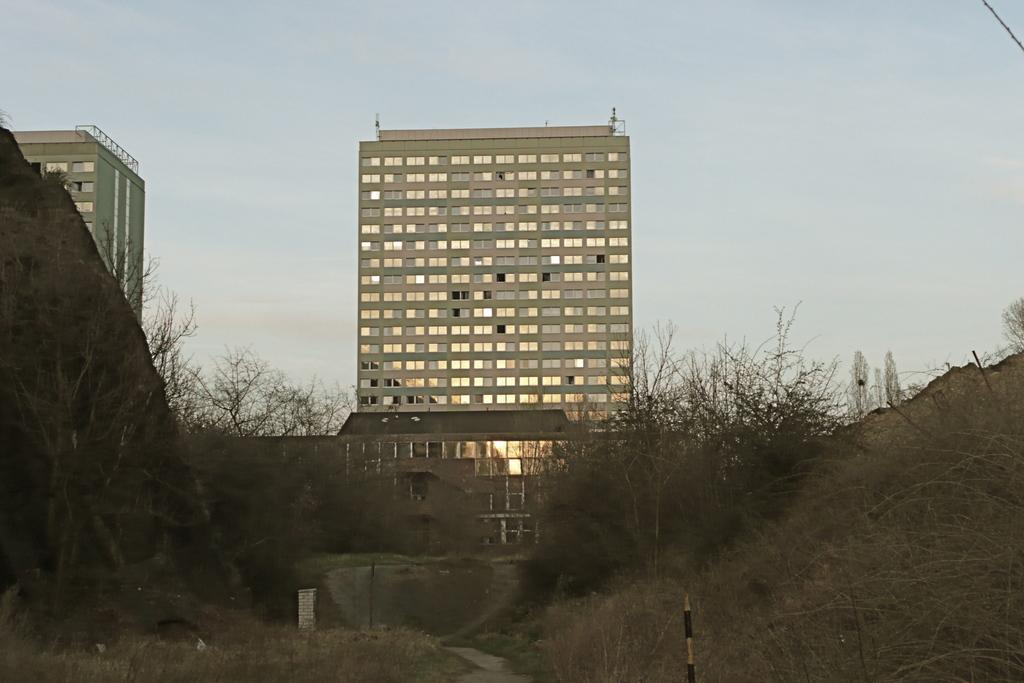What type of natural elements can be seen in the image? There are trees in the image. What type of man-made structures are present in the image? There are buildings in the image. What part of the natural environment is visible in the image? The sky is visible in the image. What type of faucet can be seen in the image? There is no faucet present in the image. Is there a rainstorm occurring in the image? There is no indication of a rainstorm in the image. 